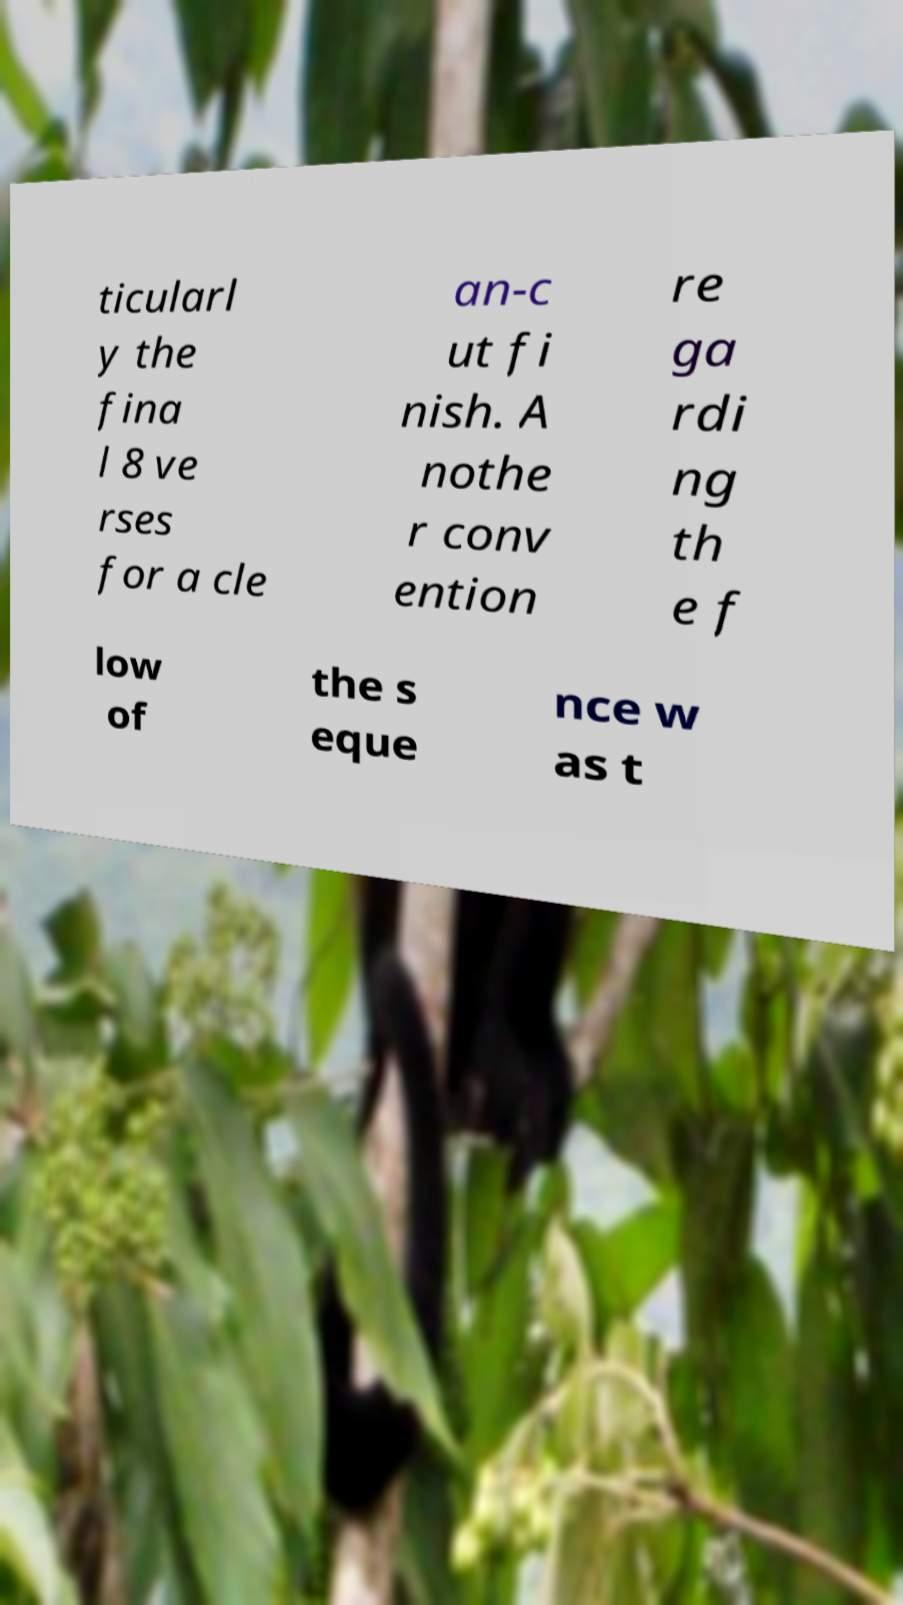Could you extract and type out the text from this image? ticularl y the fina l 8 ve rses for a cle an-c ut fi nish. A nothe r conv ention re ga rdi ng th e f low of the s eque nce w as t 